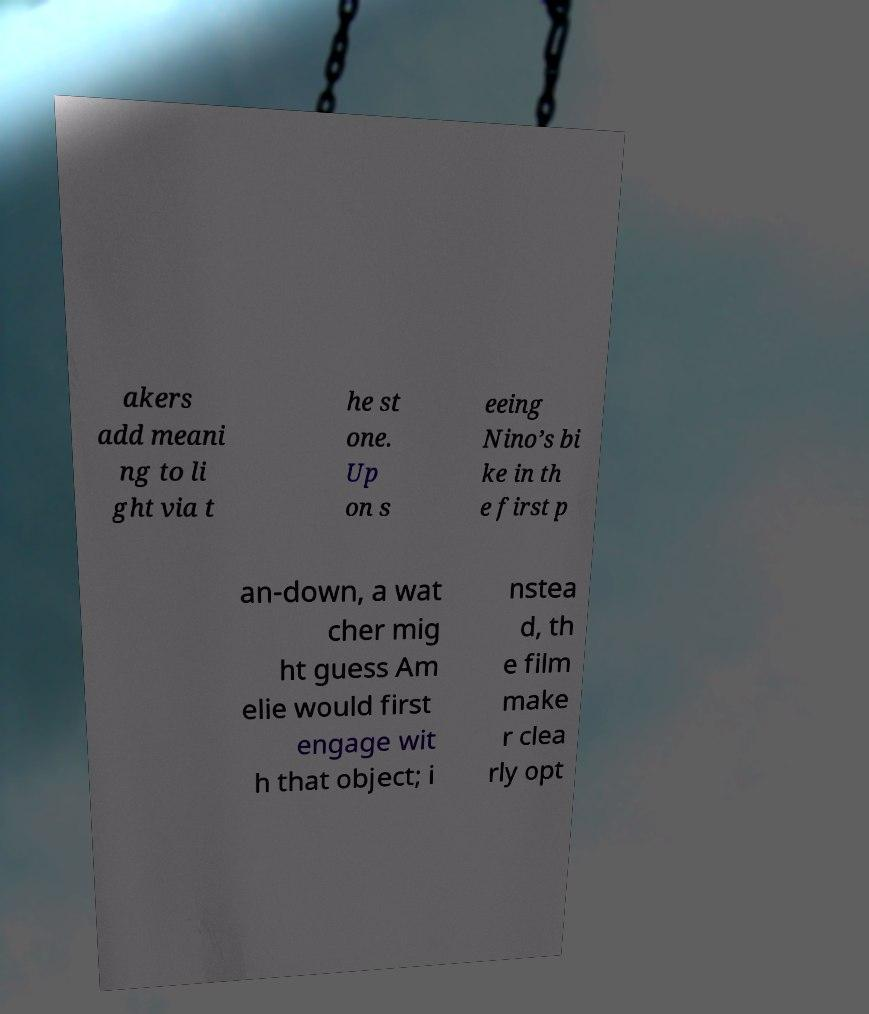Can you accurately transcribe the text from the provided image for me? akers add meani ng to li ght via t he st one. Up on s eeing Nino’s bi ke in th e first p an-down, a wat cher mig ht guess Am elie would first engage wit h that object; i nstea d, th e film make r clea rly opt 